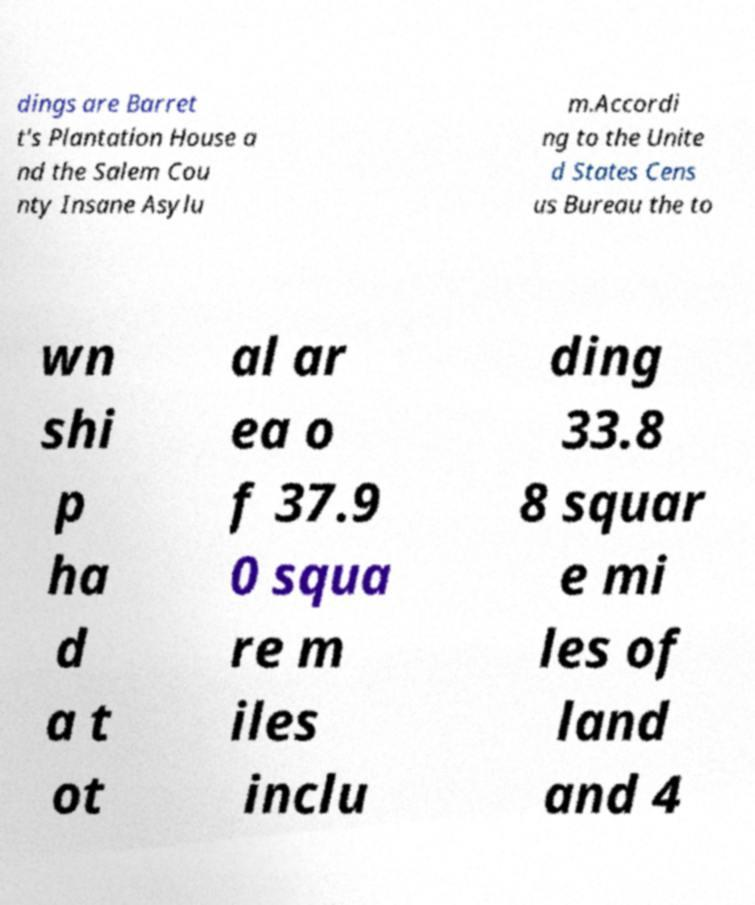Could you extract and type out the text from this image? dings are Barret t's Plantation House a nd the Salem Cou nty Insane Asylu m.Accordi ng to the Unite d States Cens us Bureau the to wn shi p ha d a t ot al ar ea o f 37.9 0 squa re m iles inclu ding 33.8 8 squar e mi les of land and 4 